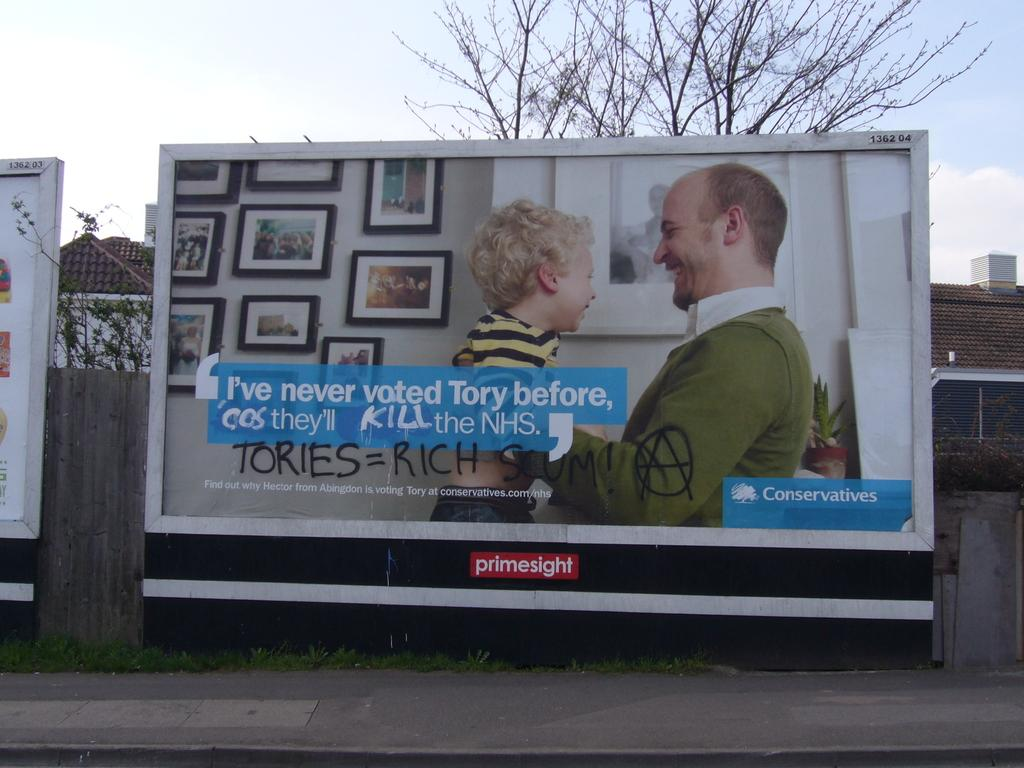<image>
Provide a brief description of the given image. A billboard for the Conservatives is about voting for the Tory party. 